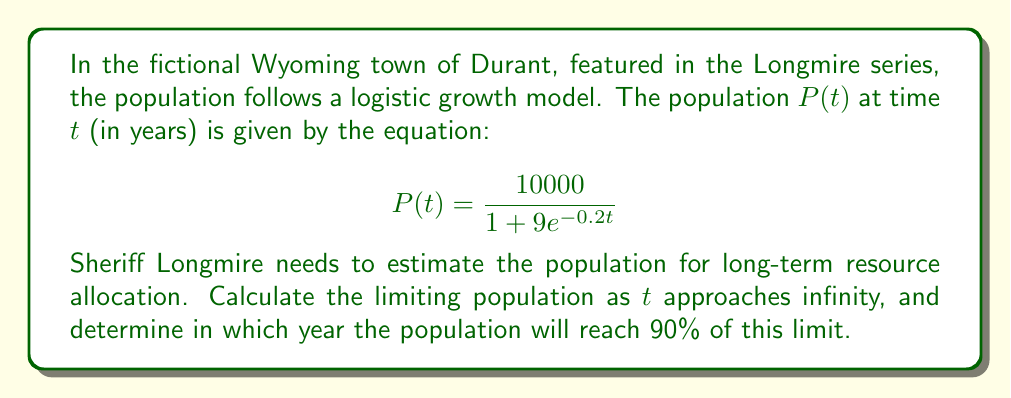Give your solution to this math problem. To solve this problem, we'll follow these steps:

1. Find the limiting population:
   The logistic growth model has a horizontal asymptote that represents the carrying capacity or limiting population. As $t$ approaches infinity, $e^{-0.2t}$ approaches 0.

   $$\lim_{t \to \infty} P(t) = \frac{10000}{1 + 9 \cdot 0} = 10000$$

   So, the limiting population is 10,000.

2. Calculate 90% of the limiting population:
   $0.90 \times 10000 = 9000$

3. Solve for $t$ when $P(t) = 9000$:
   $$9000 = \frac{10000}{1 + 9e^{-0.2t}}$$

   $$1 + 9e^{-0.2t} = \frac{10000}{9000} = \frac{10}{9}$$

   $$9e^{-0.2t} = \frac{10}{9} - 1 = \frac{1}{9}$$

   $$e^{-0.2t} = \frac{1}{81}$$

   $$-0.2t = \ln(\frac{1}{81}) = -\ln(81)$$

   $$t = \frac{\ln(81)}{0.2} \approx 21.95$$

The population will reach 90% of the limiting population after approximately 22 years.
Answer: The limiting population is 10,000, and the population will reach 90% of this limit (9,000) after approximately 22 years. 